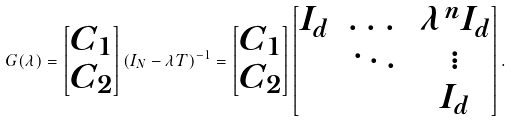<formula> <loc_0><loc_0><loc_500><loc_500>G ( \lambda ) = \begin{bmatrix} C _ { 1 } \\ C _ { 2 } \end{bmatrix} ( I _ { N } - \lambda T ) ^ { - 1 } = \begin{bmatrix} C _ { 1 } \\ C _ { 2 } \end{bmatrix} \begin{bmatrix} I _ { d } & \dots & \lambda ^ { n } I _ { d } \\ & \ddots & \vdots \\ & & I _ { d } \end{bmatrix} .</formula> 